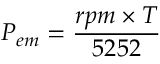Convert formula to latex. <formula><loc_0><loc_0><loc_500><loc_500>P _ { e m } = { \frac { r p m \times T } { 5 2 5 2 } }</formula> 